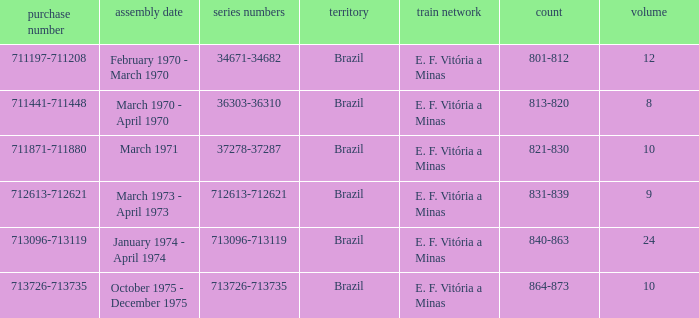The numbers 801-812 are in which country? Brazil. 